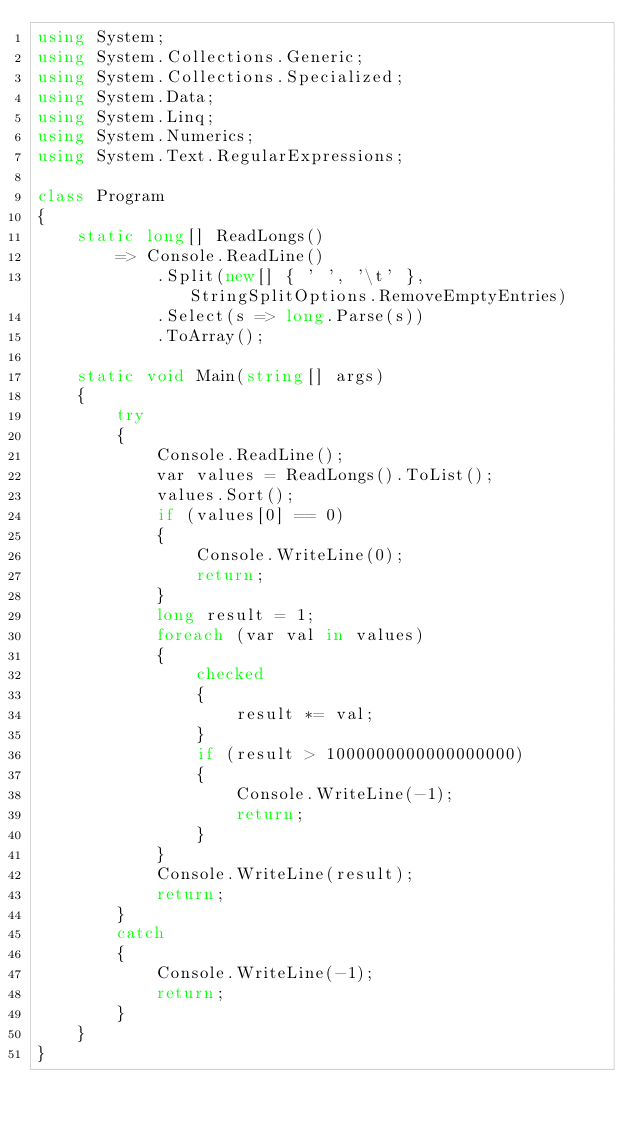Convert code to text. <code><loc_0><loc_0><loc_500><loc_500><_C#_>using System;
using System.Collections.Generic;
using System.Collections.Specialized;
using System.Data;
using System.Linq;
using System.Numerics;
using System.Text.RegularExpressions;

class Program
{
    static long[] ReadLongs()
        => Console.ReadLine()
            .Split(new[] { ' ', '\t' }, StringSplitOptions.RemoveEmptyEntries)
            .Select(s => long.Parse(s))
            .ToArray();

    static void Main(string[] args)
    {
        try
        {
            Console.ReadLine();
            var values = ReadLongs().ToList();
            values.Sort();
            if (values[0] == 0)
            {
                Console.WriteLine(0);
                return;
            }
            long result = 1;
            foreach (var val in values)
            {
                checked
                {
                    result *= val;
                }
                if (result > 1000000000000000000)
                {
                    Console.WriteLine(-1);
                    return;
                }
            }
            Console.WriteLine(result);
            return;
        }
        catch
        {
            Console.WriteLine(-1);
            return;
        }
    }
}</code> 